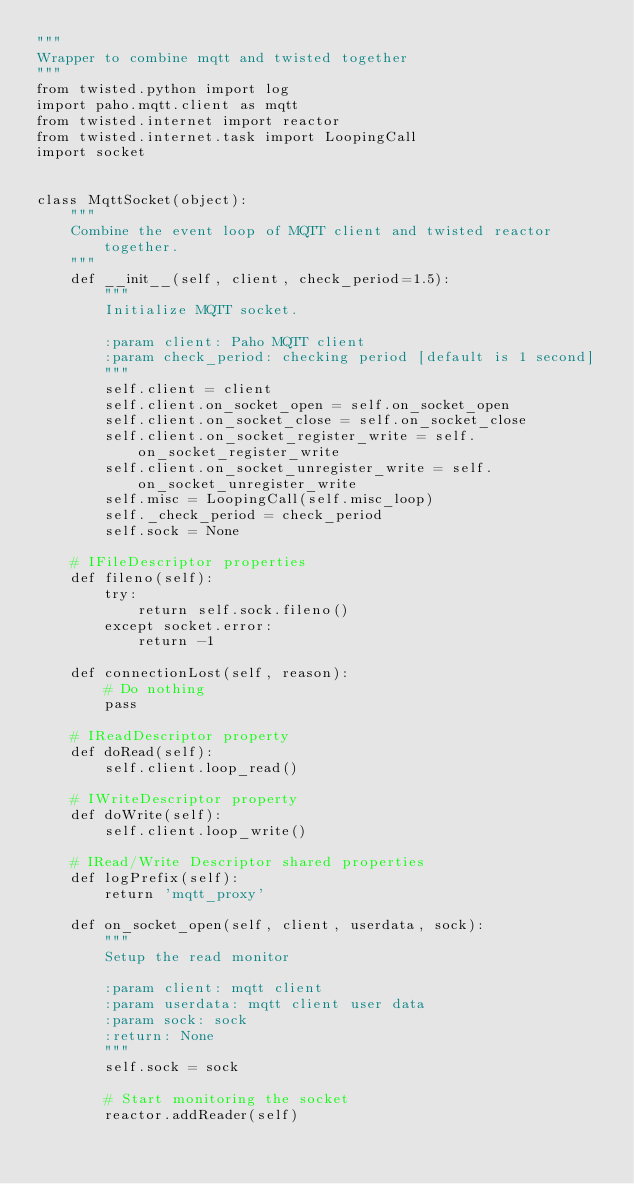Convert code to text. <code><loc_0><loc_0><loc_500><loc_500><_Python_>"""
Wrapper to combine mqtt and twisted together
"""
from twisted.python import log
import paho.mqtt.client as mqtt
from twisted.internet import reactor
from twisted.internet.task import LoopingCall
import socket


class MqttSocket(object):
    """
    Combine the event loop of MQTT client and twisted reactor together.
    """
    def __init__(self, client, check_period=1.5):
        """
        Initialize MQTT socket.

        :param client: Paho MQTT client
        :param check_period: checking period [default is 1 second]
        """
        self.client = client
        self.client.on_socket_open = self.on_socket_open
        self.client.on_socket_close = self.on_socket_close
        self.client.on_socket_register_write = self.on_socket_register_write
        self.client.on_socket_unregister_write = self.on_socket_unregister_write
        self.misc = LoopingCall(self.misc_loop)
        self._check_period = check_period
        self.sock = None

    # IFileDescriptor properties
    def fileno(self):
        try:
            return self.sock.fileno()
        except socket.error:
            return -1

    def connectionLost(self, reason):
        # Do nothing
        pass

    # IReadDescriptor property
    def doRead(self):
        self.client.loop_read()

    # IWriteDescriptor property
    def doWrite(self):
        self.client.loop_write()

    # IRead/Write Descriptor shared properties
    def logPrefix(self):
        return 'mqtt_proxy'

    def on_socket_open(self, client, userdata, sock):
        """
        Setup the read monitor

        :param client: mqtt client
        :param userdata: mqtt client user data
        :param sock: sock
        :return: None
        """
        self.sock = sock

        # Start monitoring the socket
        reactor.addReader(self)</code> 